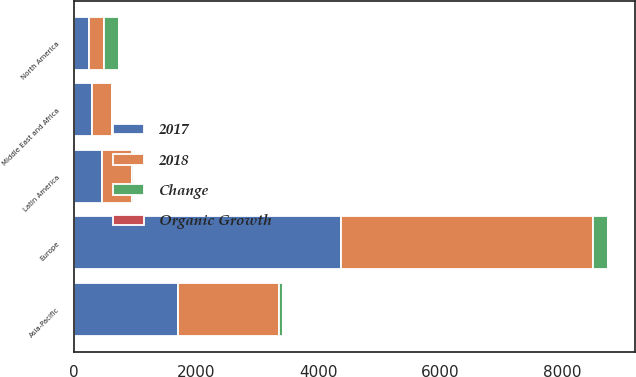Convert chart. <chart><loc_0><loc_0><loc_500><loc_500><stacked_bar_chart><ecel><fcel>North America<fcel>Latin America<fcel>Europe<fcel>Middle East and Africa<fcel>Asia-Pacific<nl><fcel>2017<fcel>245.5<fcel>457.5<fcel>4375.4<fcel>304.4<fcel>1710.4<nl><fcel>2018<fcel>245.5<fcel>494.8<fcel>4127.9<fcel>314.6<fcel>1650.3<nl><fcel>Change<fcel>243.5<fcel>37.3<fcel>247.5<fcel>10.2<fcel>60.1<nl><fcel>Organic Growth<fcel>0.4<fcel>2<fcel>5.7<fcel>2.9<fcel>7.9<nl></chart> 